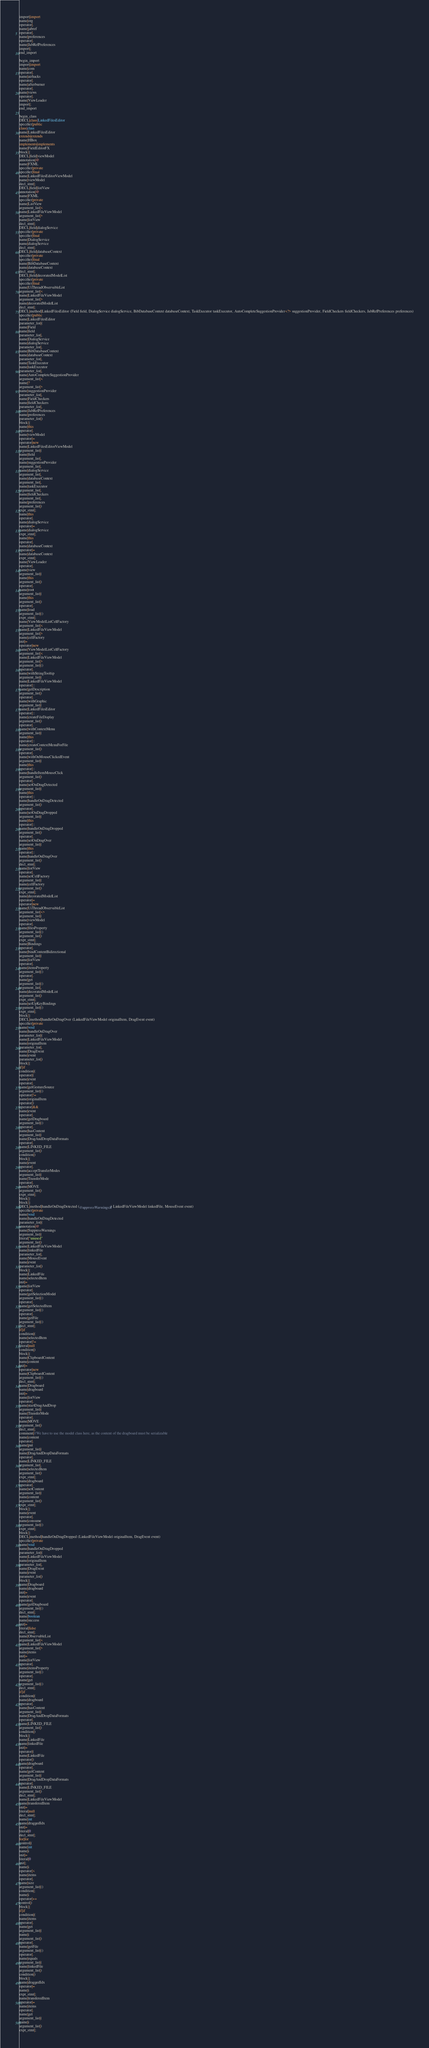Convert code to text. <code><loc_0><loc_0><loc_500><loc_500><_Java_>import|import
name|org
operator|.
name|jabref
operator|.
name|preferences
operator|.
name|JabRefPreferences
import|;
end_import

begin_import
import|import
name|com
operator|.
name|airhacks
operator|.
name|afterburner
operator|.
name|views
operator|.
name|ViewLoader
import|;
end_import

begin_class
DECL|class|LinkedFilesEditor
specifier|public
class|class
name|LinkedFilesEditor
extends|extends
name|HBox
implements|implements
name|FieldEditorFX
block|{
DECL|field|viewModel
annotation|@
name|FXML
specifier|private
specifier|final
name|LinkedFilesEditorViewModel
name|viewModel
decl_stmt|;
DECL|field|listView
annotation|@
name|FXML
specifier|private
name|ListView
argument_list|<
name|LinkedFileViewModel
argument_list|>
name|listView
decl_stmt|;
DECL|field|dialogService
specifier|private
specifier|final
name|DialogService
name|dialogService
decl_stmt|;
DECL|field|databaseContext
specifier|private
specifier|final
name|BibDatabaseContext
name|databaseContext
decl_stmt|;
DECL|field|decoratedModelList
specifier|private
specifier|final
name|UiThreadObservableList
argument_list|<
name|LinkedFileViewModel
argument_list|>
name|decoratedModelList
decl_stmt|;
DECL|method|LinkedFilesEditor (Field field, DialogService dialogService, BibDatabaseContext databaseContext, TaskExecutor taskExecutor, AutoCompleteSuggestionProvider<?> suggestionProvider, FieldCheckers fieldCheckers, JabRefPreferences preferences)
specifier|public
name|LinkedFilesEditor
parameter_list|(
name|Field
name|field
parameter_list|,
name|DialogService
name|dialogService
parameter_list|,
name|BibDatabaseContext
name|databaseContext
parameter_list|,
name|TaskExecutor
name|taskExecutor
parameter_list|,
name|AutoCompleteSuggestionProvider
argument_list|<
name|?
argument_list|>
name|suggestionProvider
parameter_list|,
name|FieldCheckers
name|fieldCheckers
parameter_list|,
name|JabRefPreferences
name|preferences
parameter_list|)
block|{
name|this
operator|.
name|viewModel
operator|=
operator|new
name|LinkedFilesEditorViewModel
argument_list|(
name|field
argument_list|,
name|suggestionProvider
argument_list|,
name|dialogService
argument_list|,
name|databaseContext
argument_list|,
name|taskExecutor
argument_list|,
name|fieldCheckers
argument_list|,
name|preferences
argument_list|)
expr_stmt|;
name|this
operator|.
name|dialogService
operator|=
name|dialogService
expr_stmt|;
name|this
operator|.
name|databaseContext
operator|=
name|databaseContext
expr_stmt|;
name|ViewLoader
operator|.
name|view
argument_list|(
name|this
argument_list|)
operator|.
name|root
argument_list|(
name|this
argument_list|)
operator|.
name|load
argument_list|()
expr_stmt|;
name|ViewModelListCellFactory
argument_list|<
name|LinkedFileViewModel
argument_list|>
name|cellFactory
init|=
operator|new
name|ViewModelListCellFactory
argument_list|<
name|LinkedFileViewModel
argument_list|>
argument_list|()
operator|.
name|withStringTooltip
argument_list|(
name|LinkedFileViewModel
operator|::
name|getDescription
argument_list|)
operator|.
name|withGraphic
argument_list|(
name|LinkedFilesEditor
operator|::
name|createFileDisplay
argument_list|)
operator|.
name|withContextMenu
argument_list|(
name|this
operator|::
name|createContextMenuForFile
argument_list|)
operator|.
name|withOnMouseClickedEvent
argument_list|(
name|this
operator|::
name|handleItemMouseClick
argument_list|)
operator|.
name|setOnDragDetected
argument_list|(
name|this
operator|::
name|handleOnDragDetected
argument_list|)
operator|.
name|setOnDragDropped
argument_list|(
name|this
operator|::
name|handleOnDragDropped
argument_list|)
operator|.
name|setOnDragOver
argument_list|(
name|this
operator|::
name|handleOnDragOver
argument_list|)
decl_stmt|;
name|listView
operator|.
name|setCellFactory
argument_list|(
name|cellFactory
argument_list|)
expr_stmt|;
name|decoratedModelList
operator|=
operator|new
name|UiThreadObservableList
argument_list|<>
argument_list|(
name|viewModel
operator|.
name|filesProperty
argument_list|()
argument_list|)
expr_stmt|;
name|Bindings
operator|.
name|bindContentBidirectional
argument_list|(
name|listView
operator|.
name|itemsProperty
argument_list|()
operator|.
name|get
argument_list|()
argument_list|,
name|decoratedModelList
argument_list|)
expr_stmt|;
name|setUpKeyBindings
argument_list|()
expr_stmt|;
block|}
DECL|method|handleOnDragOver (LinkedFileViewModel originalItem, DragEvent event)
specifier|private
name|void
name|handleOnDragOver
parameter_list|(
name|LinkedFileViewModel
name|originalItem
parameter_list|,
name|DragEvent
name|event
parameter_list|)
block|{
if|if
condition|(
operator|(
name|event
operator|.
name|getGestureSource
argument_list|()
operator|!=
name|originalItem
operator|)
operator|&&
name|event
operator|.
name|getDragboard
argument_list|()
operator|.
name|hasContent
argument_list|(
name|DragAndDropDataFormats
operator|.
name|LINKED_FILE
argument_list|)
condition|)
block|{
name|event
operator|.
name|acceptTransferModes
argument_list|(
name|TransferMode
operator|.
name|MOVE
argument_list|)
expr_stmt|;
block|}
block|}
DECL|method|handleOnDragDetected (@uppressWarningsR) LinkedFileViewModel linkedFile, MouseEvent event)
specifier|private
name|void
name|handleOnDragDetected
parameter_list|(
annotation|@
name|SuppressWarnings
argument_list|(
literal|"unused"
argument_list|)
name|LinkedFileViewModel
name|linkedFile
parameter_list|,
name|MouseEvent
name|event
parameter_list|)
block|{
name|LinkedFile
name|selectedItem
init|=
name|listView
operator|.
name|getSelectionModel
argument_list|()
operator|.
name|getSelectedItem
argument_list|()
operator|.
name|getFile
argument_list|()
decl_stmt|;
if|if
condition|(
name|selectedItem
operator|!=
literal|null
condition|)
block|{
name|ClipboardContent
name|content
init|=
operator|new
name|ClipboardContent
argument_list|()
decl_stmt|;
name|Dragboard
name|dragboard
init|=
name|listView
operator|.
name|startDragAndDrop
argument_list|(
name|TransferMode
operator|.
name|MOVE
argument_list|)
decl_stmt|;
comment|//We have to use the model class here, as the content of the dragboard must be serializable
name|content
operator|.
name|put
argument_list|(
name|DragAndDropDataFormats
operator|.
name|LINKED_FILE
argument_list|,
name|selectedItem
argument_list|)
expr_stmt|;
name|dragboard
operator|.
name|setContent
argument_list|(
name|content
argument_list|)
expr_stmt|;
block|}
name|event
operator|.
name|consume
argument_list|()
expr_stmt|;
block|}
DECL|method|handleOnDragDropped (LinkedFileViewModel originalItem, DragEvent event)
specifier|private
name|void
name|handleOnDragDropped
parameter_list|(
name|LinkedFileViewModel
name|originalItem
parameter_list|,
name|DragEvent
name|event
parameter_list|)
block|{
name|Dragboard
name|dragboard
init|=
name|event
operator|.
name|getDragboard
argument_list|()
decl_stmt|;
name|boolean
name|success
init|=
literal|false
decl_stmt|;
name|ObservableList
argument_list|<
name|LinkedFileViewModel
argument_list|>
name|items
init|=
name|listView
operator|.
name|itemsProperty
argument_list|()
operator|.
name|get
argument_list|()
decl_stmt|;
if|if
condition|(
name|dragboard
operator|.
name|hasContent
argument_list|(
name|DragAndDropDataFormats
operator|.
name|LINKED_FILE
argument_list|)
condition|)
block|{
name|LinkedFile
name|linkedFile
init|=
operator|(
name|LinkedFile
operator|)
name|dragboard
operator|.
name|getContent
argument_list|(
name|DragAndDropDataFormats
operator|.
name|LINKED_FILE
argument_list|)
decl_stmt|;
name|LinkedFileViewModel
name|transferedItem
init|=
literal|null
decl_stmt|;
name|int
name|draggedIdx
init|=
literal|0
decl_stmt|;
for|for
control|(
name|int
name|i
init|=
literal|0
init|;
name|i
operator|<
name|items
operator|.
name|size
argument_list|()
condition|;
name|i
operator|++
control|)
block|{
if|if
condition|(
name|items
operator|.
name|get
argument_list|(
name|i
argument_list|)
operator|.
name|getFile
argument_list|()
operator|.
name|equals
argument_list|(
name|linkedFile
argument_list|)
condition|)
block|{
name|draggedIdx
operator|=
name|i
expr_stmt|;
name|transferedItem
operator|=
name|items
operator|.
name|get
argument_list|(
name|i
argument_list|)
expr_stmt|;</code> 